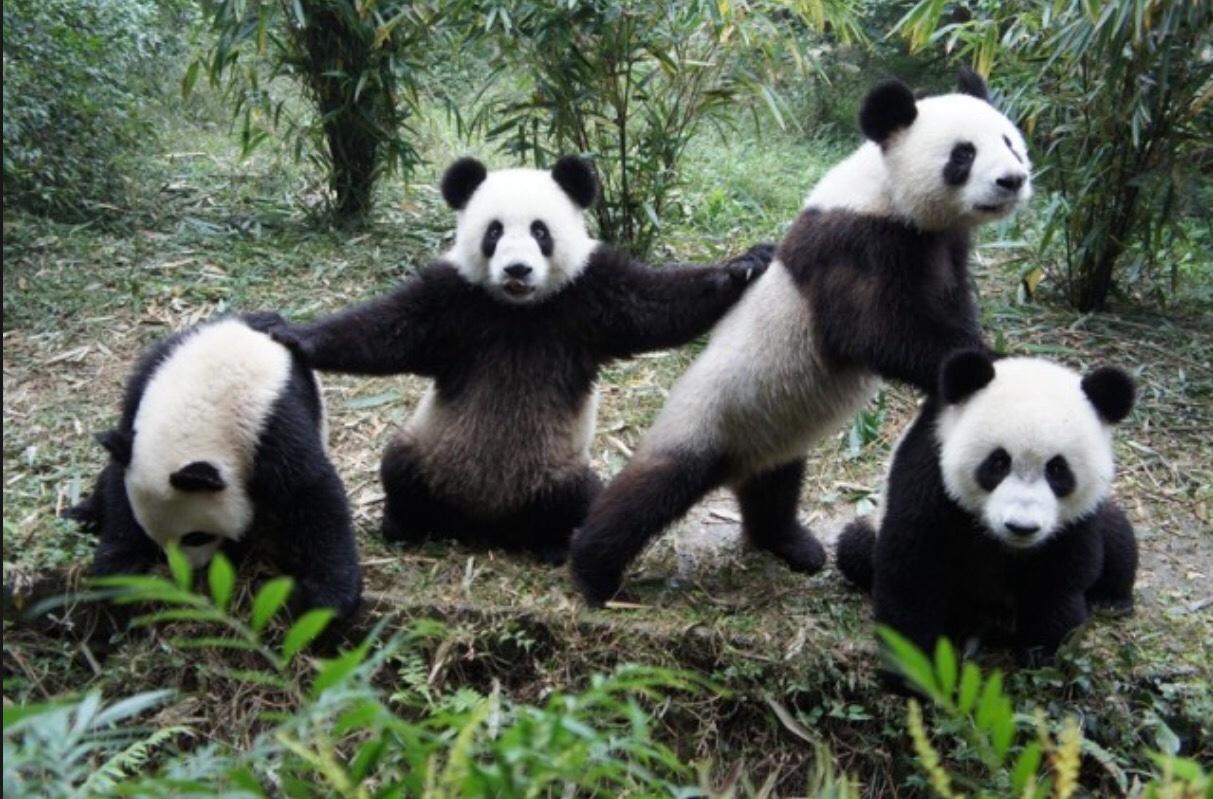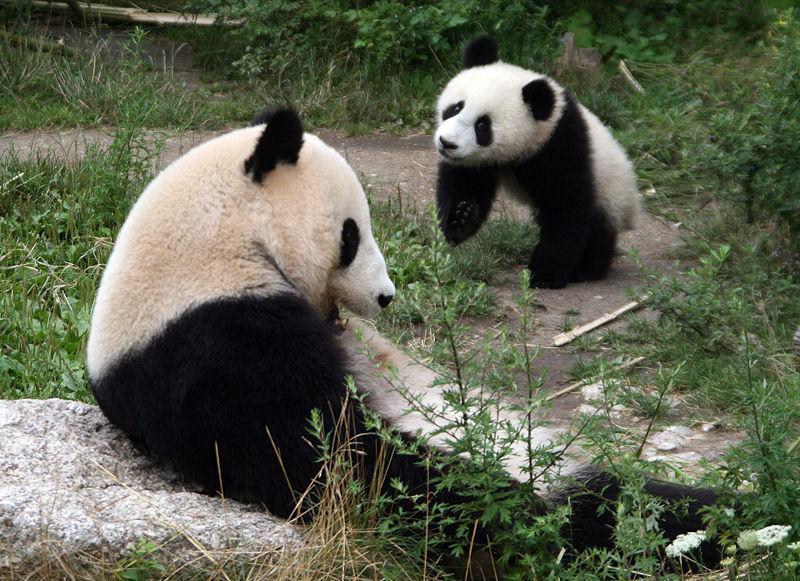The first image is the image on the left, the second image is the image on the right. Examine the images to the left and right. Is the description "There are three panda bears" accurate? Answer yes or no. No. The first image is the image on the left, the second image is the image on the right. Analyze the images presented: Is the assertion "An image shows an adult panda on its back, playing with a young panda on top." valid? Answer yes or no. No. 